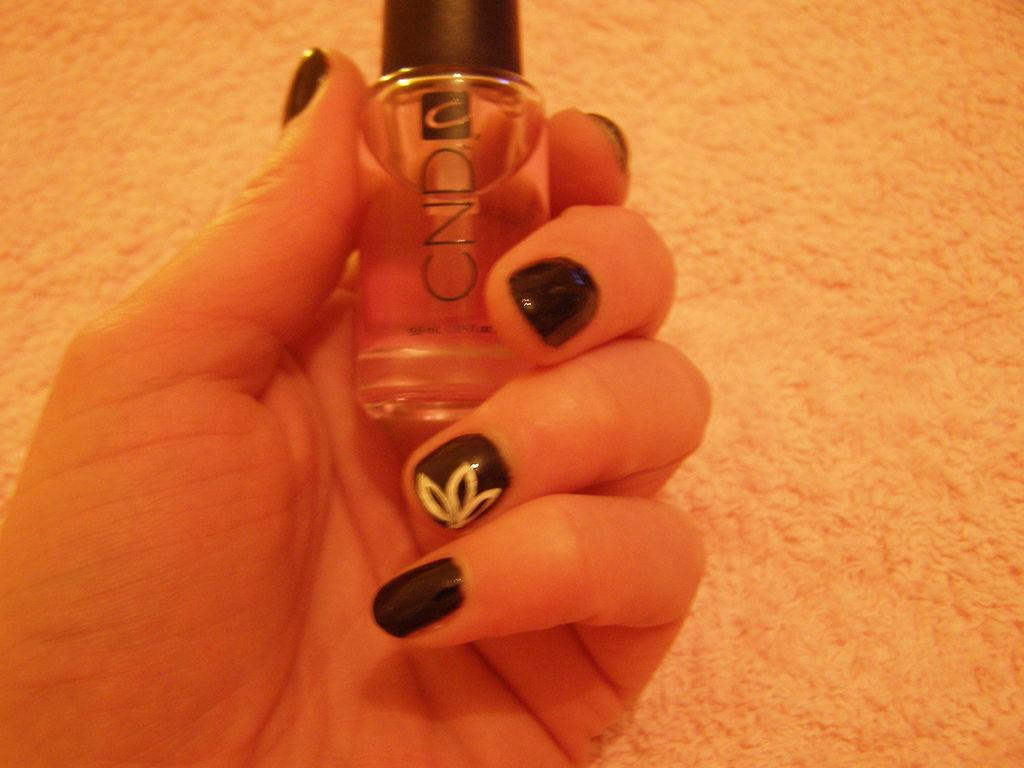<image>
Give a short and clear explanation of the subsequent image. A woman's nails are nicely painted using CND brand nail polish. 